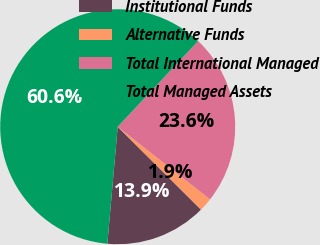Convert chart. <chart><loc_0><loc_0><loc_500><loc_500><pie_chart><fcel>Institutional Funds<fcel>Alternative Funds<fcel>Total International Managed<fcel>Total Managed Assets<nl><fcel>13.94%<fcel>1.86%<fcel>23.61%<fcel>60.59%<nl></chart> 